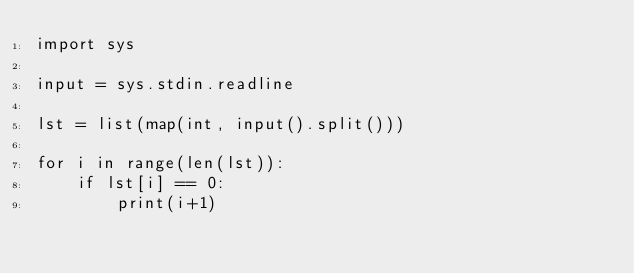<code> <loc_0><loc_0><loc_500><loc_500><_Python_>import sys

input = sys.stdin.readline

lst = list(map(int, input().split()))

for i in range(len(lst)):
    if lst[i] == 0:
        print(i+1)
</code> 